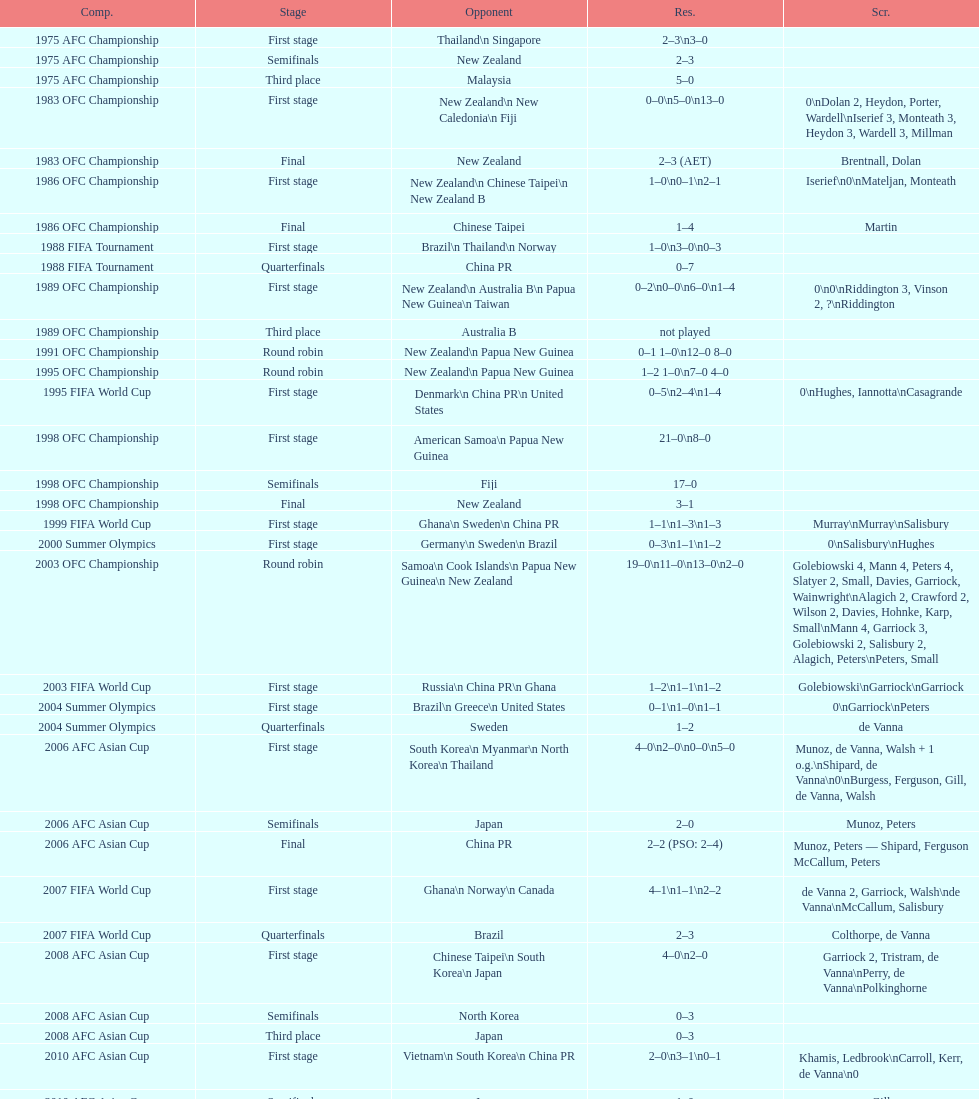What was the total goals made in the 1983 ofc championship? 18. Would you mind parsing the complete table? {'header': ['Comp.', 'Stage', 'Opponent', 'Res.', 'Scr.'], 'rows': [['1975 AFC Championship', 'First stage', 'Thailand\\n\xa0Singapore', '2–3\\n3–0', ''], ['1975 AFC Championship', 'Semifinals', 'New Zealand', '2–3', ''], ['1975 AFC Championship', 'Third place', 'Malaysia', '5–0', ''], ['1983 OFC Championship', 'First stage', 'New Zealand\\n\xa0New Caledonia\\n\xa0Fiji', '0–0\\n5–0\\n13–0', '0\\nDolan 2, Heydon, Porter, Wardell\\nIserief 3, Monteath 3, Heydon 3, Wardell 3, Millman'], ['1983 OFC Championship', 'Final', 'New Zealand', '2–3 (AET)', 'Brentnall, Dolan'], ['1986 OFC Championship', 'First stage', 'New Zealand\\n\xa0Chinese Taipei\\n New Zealand B', '1–0\\n0–1\\n2–1', 'Iserief\\n0\\nMateljan, Monteath'], ['1986 OFC Championship', 'Final', 'Chinese Taipei', '1–4', 'Martin'], ['1988 FIFA Tournament', 'First stage', 'Brazil\\n\xa0Thailand\\n\xa0Norway', '1–0\\n3–0\\n0–3', ''], ['1988 FIFA Tournament', 'Quarterfinals', 'China PR', '0–7', ''], ['1989 OFC Championship', 'First stage', 'New Zealand\\n Australia B\\n\xa0Papua New Guinea\\n\xa0Taiwan', '0–2\\n0–0\\n6–0\\n1–4', '0\\n0\\nRiddington 3, Vinson 2,\xa0?\\nRiddington'], ['1989 OFC Championship', 'Third place', 'Australia B', 'not played', ''], ['1991 OFC Championship', 'Round robin', 'New Zealand\\n\xa0Papua New Guinea', '0–1 1–0\\n12–0 8–0', ''], ['1995 OFC Championship', 'Round robin', 'New Zealand\\n\xa0Papua New Guinea', '1–2 1–0\\n7–0 4–0', ''], ['1995 FIFA World Cup', 'First stage', 'Denmark\\n\xa0China PR\\n\xa0United States', '0–5\\n2–4\\n1–4', '0\\nHughes, Iannotta\\nCasagrande'], ['1998 OFC Championship', 'First stage', 'American Samoa\\n\xa0Papua New Guinea', '21–0\\n8–0', ''], ['1998 OFC Championship', 'Semifinals', 'Fiji', '17–0', ''], ['1998 OFC Championship', 'Final', 'New Zealand', '3–1', ''], ['1999 FIFA World Cup', 'First stage', 'Ghana\\n\xa0Sweden\\n\xa0China PR', '1–1\\n1–3\\n1–3', 'Murray\\nMurray\\nSalisbury'], ['2000 Summer Olympics', 'First stage', 'Germany\\n\xa0Sweden\\n\xa0Brazil', '0–3\\n1–1\\n1–2', '0\\nSalisbury\\nHughes'], ['2003 OFC Championship', 'Round robin', 'Samoa\\n\xa0Cook Islands\\n\xa0Papua New Guinea\\n\xa0New Zealand', '19–0\\n11–0\\n13–0\\n2–0', 'Golebiowski 4, Mann 4, Peters 4, Slatyer 2, Small, Davies, Garriock, Wainwright\\nAlagich 2, Crawford 2, Wilson 2, Davies, Hohnke, Karp, Small\\nMann 4, Garriock 3, Golebiowski 2, Salisbury 2, Alagich, Peters\\nPeters, Small'], ['2003 FIFA World Cup', 'First stage', 'Russia\\n\xa0China PR\\n\xa0Ghana', '1–2\\n1–1\\n1–2', 'Golebiowski\\nGarriock\\nGarriock'], ['2004 Summer Olympics', 'First stage', 'Brazil\\n\xa0Greece\\n\xa0United States', '0–1\\n1–0\\n1–1', '0\\nGarriock\\nPeters'], ['2004 Summer Olympics', 'Quarterfinals', 'Sweden', '1–2', 'de Vanna'], ['2006 AFC Asian Cup', 'First stage', 'South Korea\\n\xa0Myanmar\\n\xa0North Korea\\n\xa0Thailand', '4–0\\n2–0\\n0–0\\n5–0', 'Munoz, de Vanna, Walsh + 1 o.g.\\nShipard, de Vanna\\n0\\nBurgess, Ferguson, Gill, de Vanna, Walsh'], ['2006 AFC Asian Cup', 'Semifinals', 'Japan', '2–0', 'Munoz, Peters'], ['2006 AFC Asian Cup', 'Final', 'China PR', '2–2 (PSO: 2–4)', 'Munoz, Peters — Shipard, Ferguson McCallum, Peters'], ['2007 FIFA World Cup', 'First stage', 'Ghana\\n\xa0Norway\\n\xa0Canada', '4–1\\n1–1\\n2–2', 'de Vanna 2, Garriock, Walsh\\nde Vanna\\nMcCallum, Salisbury'], ['2007 FIFA World Cup', 'Quarterfinals', 'Brazil', '2–3', 'Colthorpe, de Vanna'], ['2008 AFC Asian Cup', 'First stage', 'Chinese Taipei\\n\xa0South Korea\\n\xa0Japan', '4–0\\n2–0', 'Garriock 2, Tristram, de Vanna\\nPerry, de Vanna\\nPolkinghorne'], ['2008 AFC Asian Cup', 'Semifinals', 'North Korea', '0–3', ''], ['2008 AFC Asian Cup', 'Third place', 'Japan', '0–3', ''], ['2010 AFC Asian Cup', 'First stage', 'Vietnam\\n\xa0South Korea\\n\xa0China PR', '2–0\\n3–1\\n0–1', 'Khamis, Ledbrook\\nCarroll, Kerr, de Vanna\\n0'], ['2010 AFC Asian Cup', 'Semifinals', 'Japan', '1–0', 'Gill'], ['2010 AFC Asian Cup', 'Final', 'North Korea', '1–1 (PSO: 5–4)', 'Kerr — PSO: Shipard, Ledbrook, Gill, Garriock, Simon'], ['2011 FIFA World Cup', 'First stage', 'Brazil\\n\xa0Equatorial Guinea\\n\xa0Norway', '0–1\\n3–2\\n2–1', '0\\nvan Egmond, Khamis, de Vanna\\nSimon 2'], ['2011 FIFA World Cup', 'Quarterfinals', 'Sweden', '1–3', 'Perry'], ['2012 Summer Olympics\\nAFC qualification', 'Final round', 'North Korea\\n\xa0Thailand\\n\xa0Japan\\n\xa0China PR\\n\xa0South Korea', '0–1\\n5–1\\n0–1\\n1–0\\n2–1', '0\\nHeyman 2, Butt, van Egmond, Simon\\n0\\nvan Egmond\\nButt, de Vanna'], ['2014 AFC Asian Cup', 'First stage', 'Japan\\n\xa0Jordan\\n\xa0Vietnam', 'TBD\\nTBD\\nTBD', '']]} 